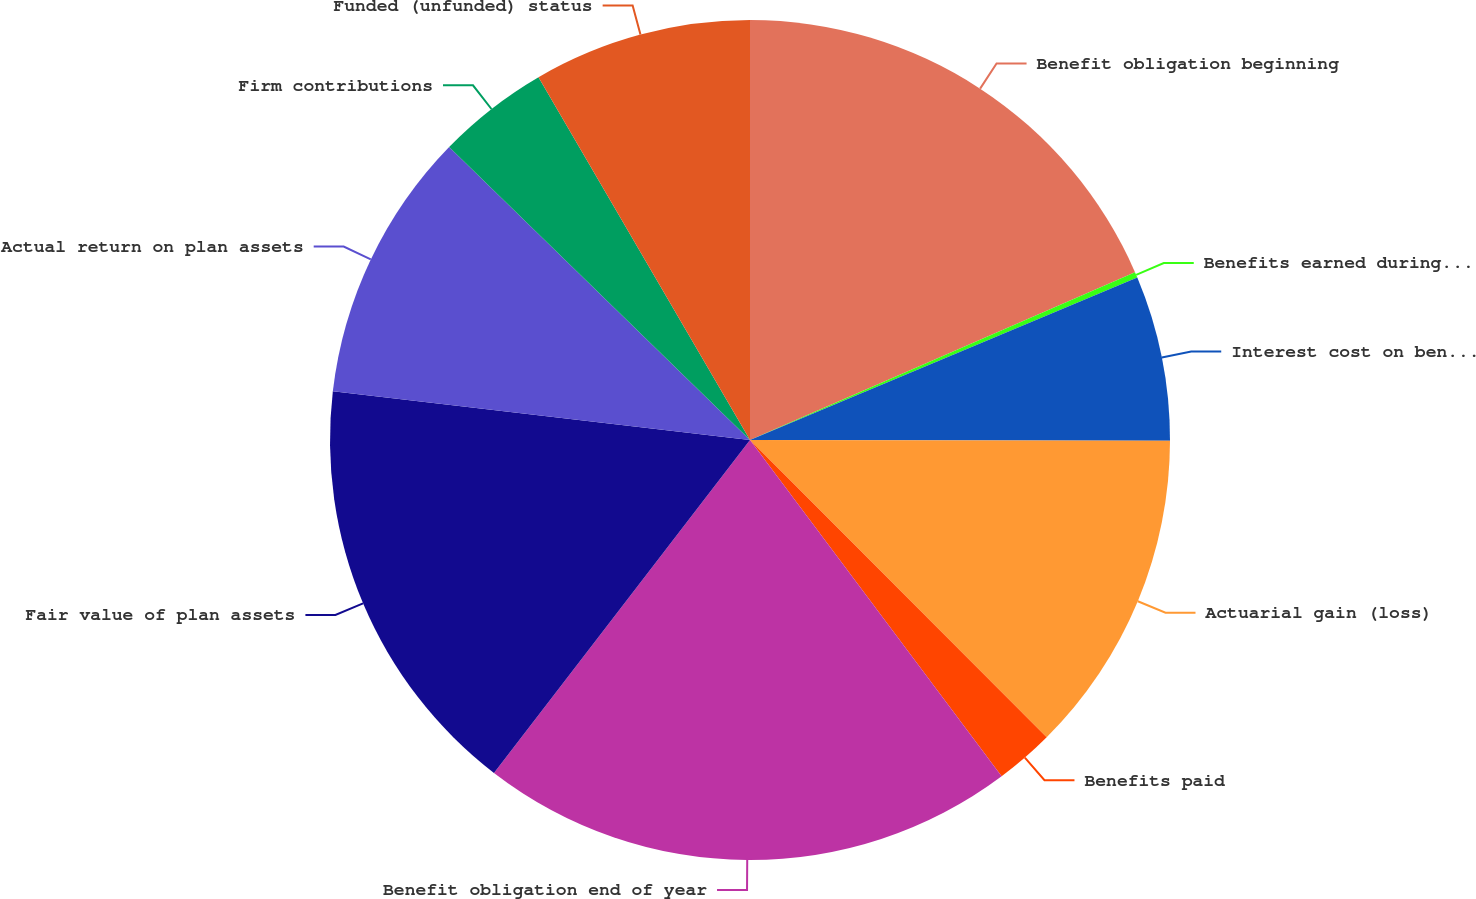<chart> <loc_0><loc_0><loc_500><loc_500><pie_chart><fcel>Benefit obligation beginning<fcel>Benefits earned during the<fcel>Interest cost on benefit<fcel>Actuarial gain (loss)<fcel>Benefits paid<fcel>Benefit obligation end of year<fcel>Fair value of plan assets<fcel>Actual return on plan assets<fcel>Firm contributions<fcel>Funded (unfunded) status<nl><fcel>18.46%<fcel>0.22%<fcel>6.35%<fcel>12.49%<fcel>2.26%<fcel>20.66%<fcel>16.42%<fcel>10.44%<fcel>4.31%<fcel>8.4%<nl></chart> 